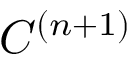Convert formula to latex. <formula><loc_0><loc_0><loc_500><loc_500>C ^ { ( n + 1 ) }</formula> 